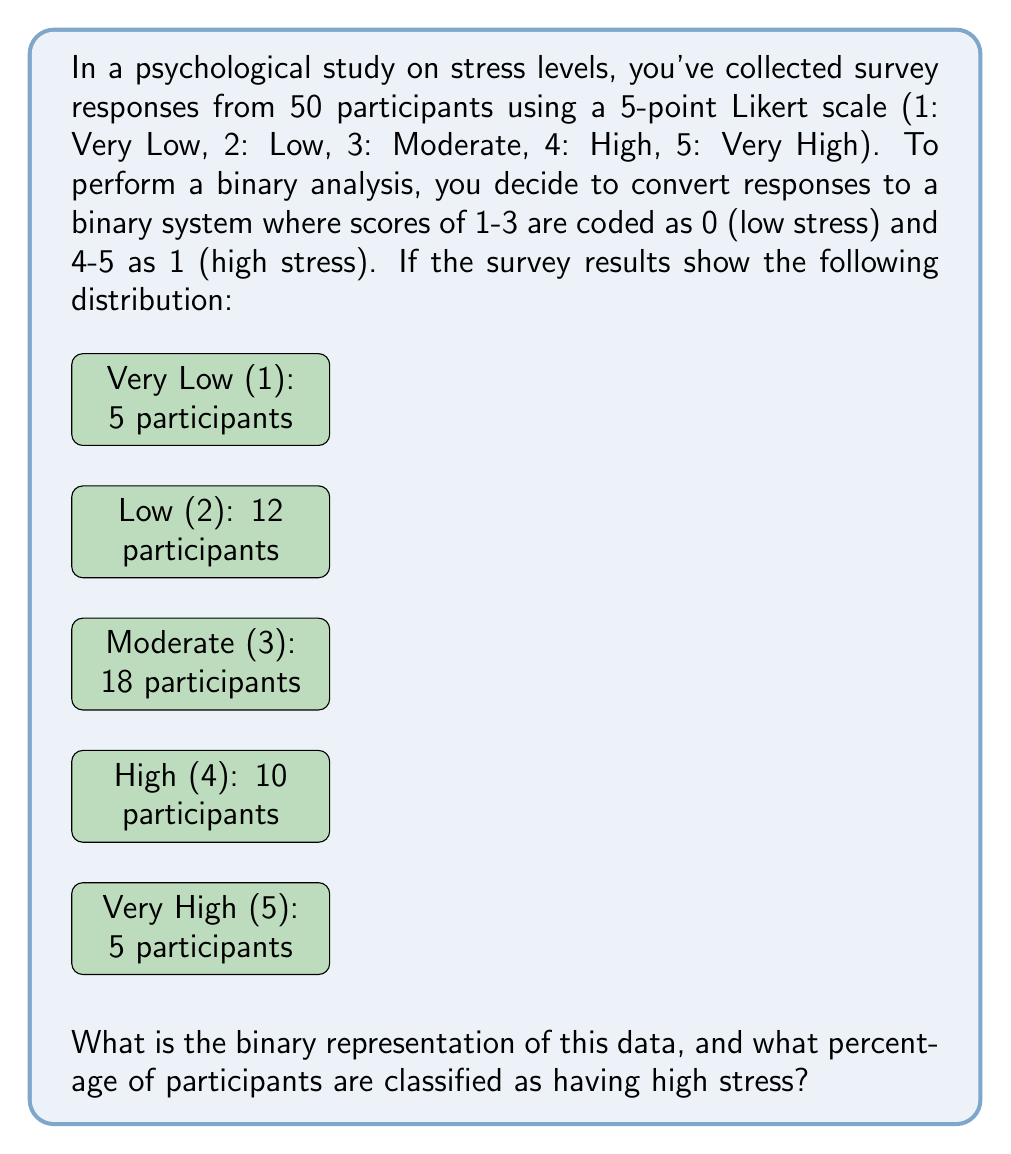Can you answer this question? Let's approach this step-by-step:

1) First, we need to convert the 5-point scale to binary:
   - Scores 1, 2, and 3 become 0 (low stress)
   - Scores 4 and 5 become 1 (high stress)

2) Now, let's count how many participants fall into each binary category:
   - Low stress (0): 5 + 12 + 18 = 35 participants
   - High stress (1): 10 + 5 = 15 participants

3) The binary representation would be a series of 35 zeros followed by 15 ones:
   $$0000000000000000000000000000000000111111111111111$$

4) To calculate the percentage of participants classified as having high stress:
   - Total participants: 50
   - Participants with high stress: 15
   - Percentage = (Number with high stress / Total participants) × 100
   $$\text{Percentage} = \frac{15}{50} \times 100 = 0.3 \times 100 = 30\%$$

Therefore, 30% of participants are classified as having high stress in this binary system.
Answer: 30% 